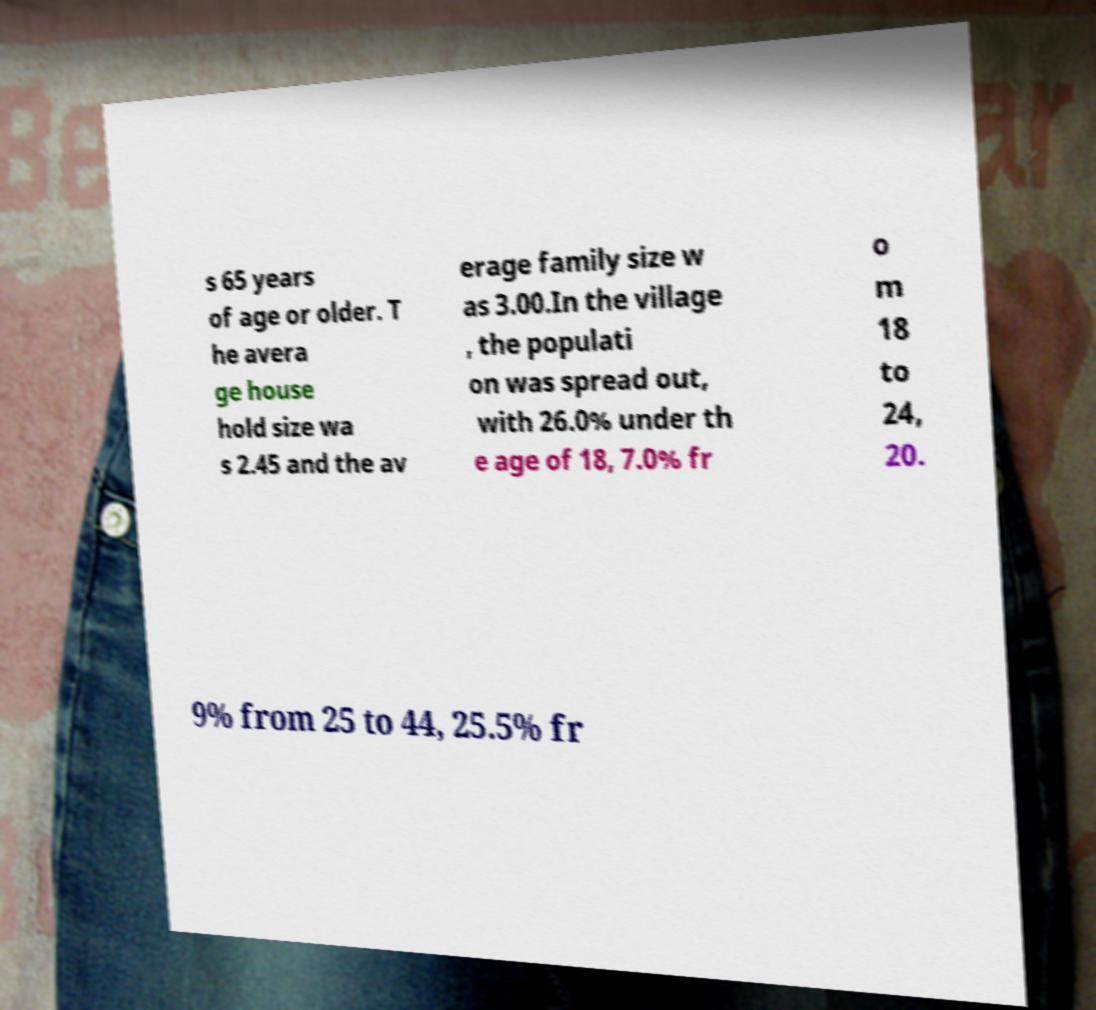Can you accurately transcribe the text from the provided image for me? s 65 years of age or older. T he avera ge house hold size wa s 2.45 and the av erage family size w as 3.00.In the village , the populati on was spread out, with 26.0% under th e age of 18, 7.0% fr o m 18 to 24, 20. 9% from 25 to 44, 25.5% fr 